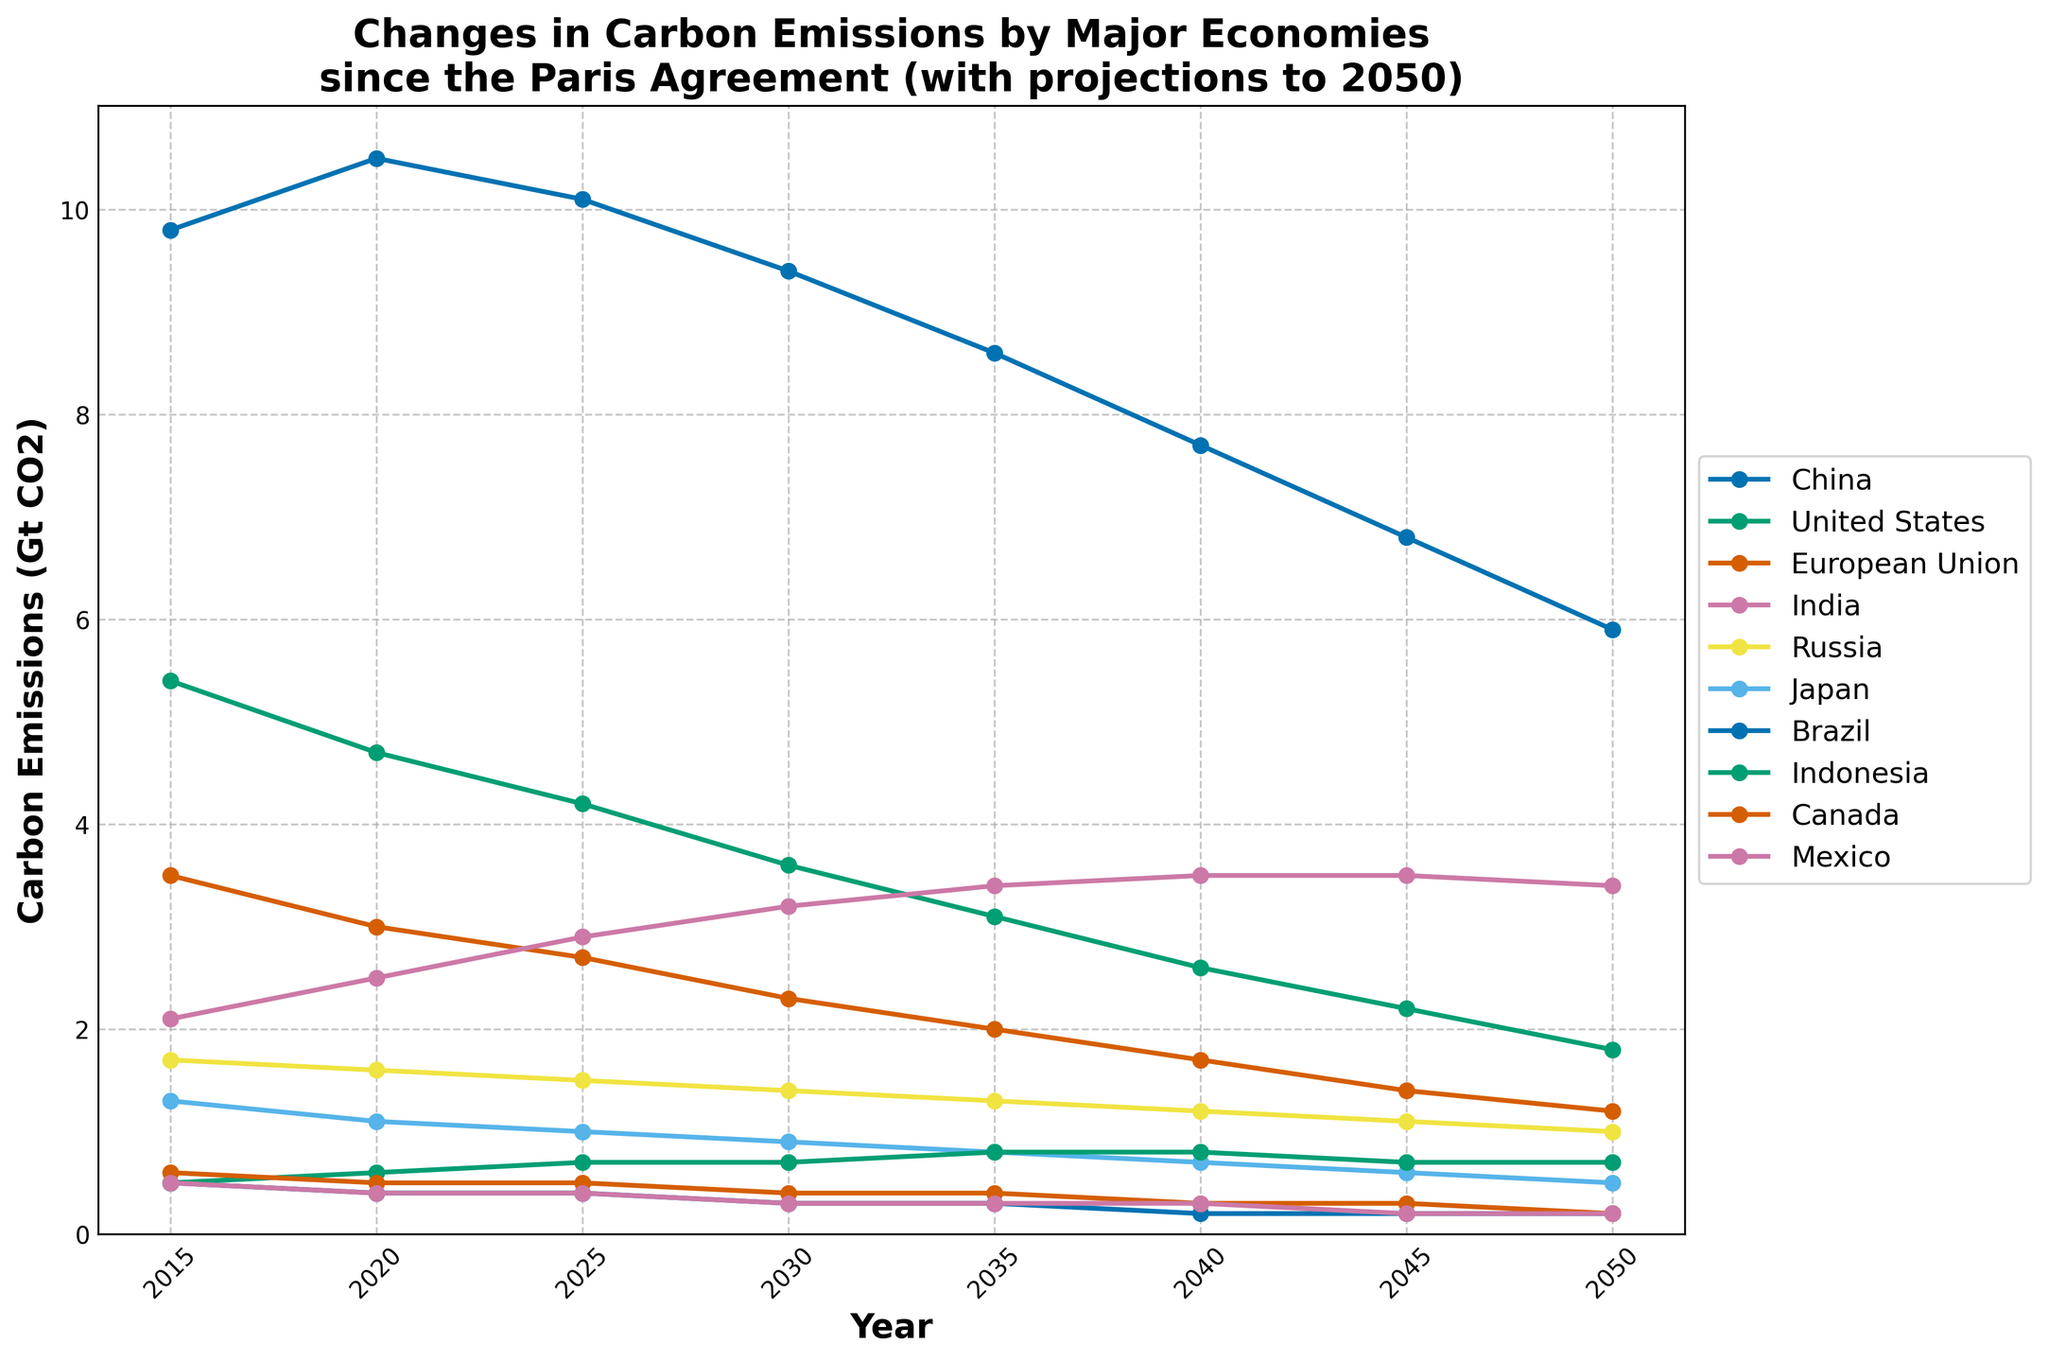Which country has the highest carbon emissions in 2015? To answer this, look at the 2015 values on the line chart and find the country with the highest point. China shows the highest value in 2015 with 9.8 Gt CO2.
Answer: China Which country has the lowest projected carbon emissions in 2050? Examine the 2050 values on the line chart and identify the country with the lowest point. Japan shows the lowest projected emissions in 2050 with 0.5 Gt CO2.
Answer: Japan What is the difference in projected carbon emissions between China and the United States in 2050? To find the difference, locate the 2050 values for China (5.9 Gt CO2) and the United States (1.8 Gt CO2), and subtract the latter from the former: 5.9 - 1.8 = 4.1 Gt CO2.
Answer: 4.1 Gt CO2 How do the carbon emissions of the European Union change from 2015 to 2050? Identify the values for the European Union in 2015 (3.5 Gt CO2) and 2050 (1.2 Gt CO2). Calculate the decrease: 3.5 - 1.2 = 2.3 Gt CO2.
Answer: Decrease by 2.3 Gt CO2 Which two countries have increasing carbon emissions from 2015 to 2050? Check the trend lines for each country from 2015 to 2050. India and Indonesia are the only countries whose lines show an overall increase from 2.1 to 3.4 Gt CO2 for India and from 0.5 to 0.7 Gt CO2 for Indonesia.
Answer: India and Indonesia How much does Russia's carbon emissions project to decrease by 2040 compared to 2015? Find Russia's values in 2015 (1.7 Gt CO2) and 2040 (1.2 Gt CO2), and calculate the difference: 1.7 - 1.2 = 0.5 Gt CO2.
Answer: 0.5 Gt CO2 In which year does Japan project to have emissions reach 0.7 Gt CO2? Follow Japan's line and find where it intersects with the value of 0.7 Gt CO2. The year is 2040.
Answer: 2040 Which country’s carbon emissions are closest to 1.0 Gt CO2 in 2030? Look for the values around 1.0 Gt CO2 in 2030. Russia has emissions of 1.4 Gt CO2, closest to 1.0 Gt CO2.
Answer: Russia Between Mexico and Canada, which has a larger decrease in carbon emissions from 2015 to 2050? Measure the decrease for Mexico and Canada from 2015 to 2050: Mexico decreases from 0.5 to 0.2 Gt CO2 (0.3 Gt CO2 decrease) and Canada decreases from 0.6 to 0.2 Gt CO2 (0.4 Gt CO2 decrease).
Answer: Canada Do the projected emissions for Brazil decrease gradually or remain stable beyond 2040? Inspect the line for Brazil from 2040 to 2050. The value remains stable at 0.2 Gt CO2.
Answer: Remain stable 